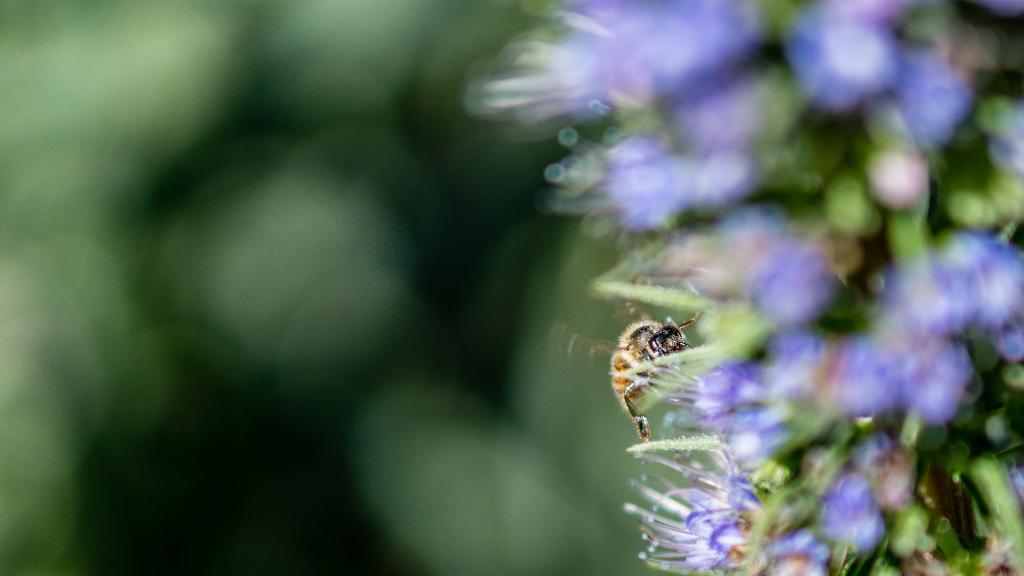How would you summarize this image in a sentence or two? In this picture we can see an insect on the flowers and we can see blurry background. 